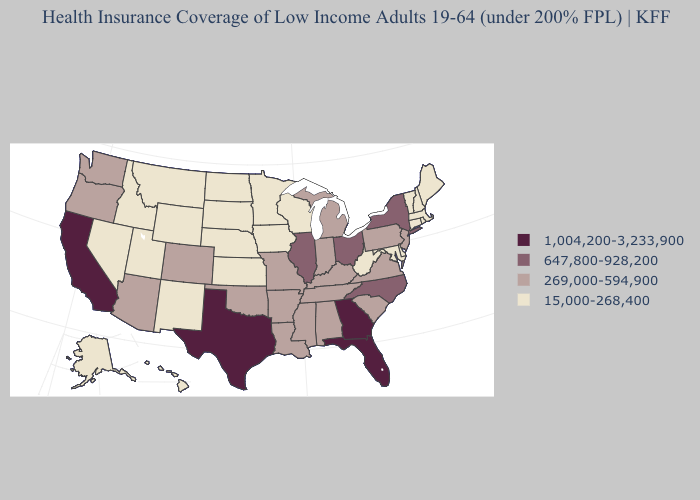Name the states that have a value in the range 15,000-268,400?
Answer briefly. Alaska, Connecticut, Delaware, Hawaii, Idaho, Iowa, Kansas, Maine, Maryland, Massachusetts, Minnesota, Montana, Nebraska, Nevada, New Hampshire, New Mexico, North Dakota, Rhode Island, South Dakota, Utah, Vermont, West Virginia, Wisconsin, Wyoming. Does Virginia have the highest value in the USA?
Short answer required. No. Name the states that have a value in the range 1,004,200-3,233,900?
Short answer required. California, Florida, Georgia, Texas. What is the highest value in states that border Vermont?
Give a very brief answer. 647,800-928,200. Does New Jersey have the lowest value in the Northeast?
Write a very short answer. No. What is the value of Utah?
Concise answer only. 15,000-268,400. What is the value of Colorado?
Keep it brief. 269,000-594,900. What is the value of California?
Concise answer only. 1,004,200-3,233,900. Does Maine have a lower value than Arizona?
Be succinct. Yes. Does New York have the highest value in the Northeast?
Short answer required. Yes. Does the map have missing data?
Be succinct. No. Name the states that have a value in the range 647,800-928,200?
Concise answer only. Illinois, New York, North Carolina, Ohio. What is the value of North Dakota?
Short answer required. 15,000-268,400. What is the value of Wisconsin?
Write a very short answer. 15,000-268,400. Name the states that have a value in the range 269,000-594,900?
Quick response, please. Alabama, Arizona, Arkansas, Colorado, Indiana, Kentucky, Louisiana, Michigan, Mississippi, Missouri, New Jersey, Oklahoma, Oregon, Pennsylvania, South Carolina, Tennessee, Virginia, Washington. 